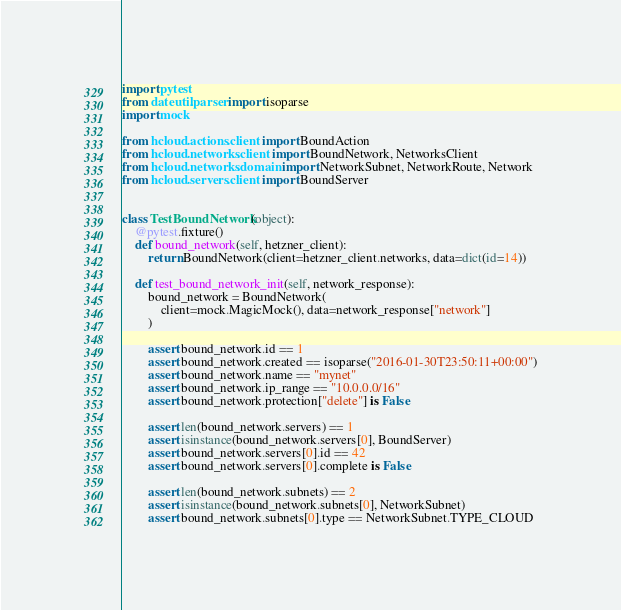Convert code to text. <code><loc_0><loc_0><loc_500><loc_500><_Python_>import pytest
from dateutil.parser import isoparse
import mock

from hcloud.actions.client import BoundAction
from hcloud.networks.client import BoundNetwork, NetworksClient
from hcloud.networks.domain import NetworkSubnet, NetworkRoute, Network
from hcloud.servers.client import BoundServer


class TestBoundNetwork(object):
    @pytest.fixture()
    def bound_network(self, hetzner_client):
        return BoundNetwork(client=hetzner_client.networks, data=dict(id=14))

    def test_bound_network_init(self, network_response):
        bound_network = BoundNetwork(
            client=mock.MagicMock(), data=network_response["network"]
        )

        assert bound_network.id == 1
        assert bound_network.created == isoparse("2016-01-30T23:50:11+00:00")
        assert bound_network.name == "mynet"
        assert bound_network.ip_range == "10.0.0.0/16"
        assert bound_network.protection["delete"] is False

        assert len(bound_network.servers) == 1
        assert isinstance(bound_network.servers[0], BoundServer)
        assert bound_network.servers[0].id == 42
        assert bound_network.servers[0].complete is False

        assert len(bound_network.subnets) == 2
        assert isinstance(bound_network.subnets[0], NetworkSubnet)
        assert bound_network.subnets[0].type == NetworkSubnet.TYPE_CLOUD</code> 